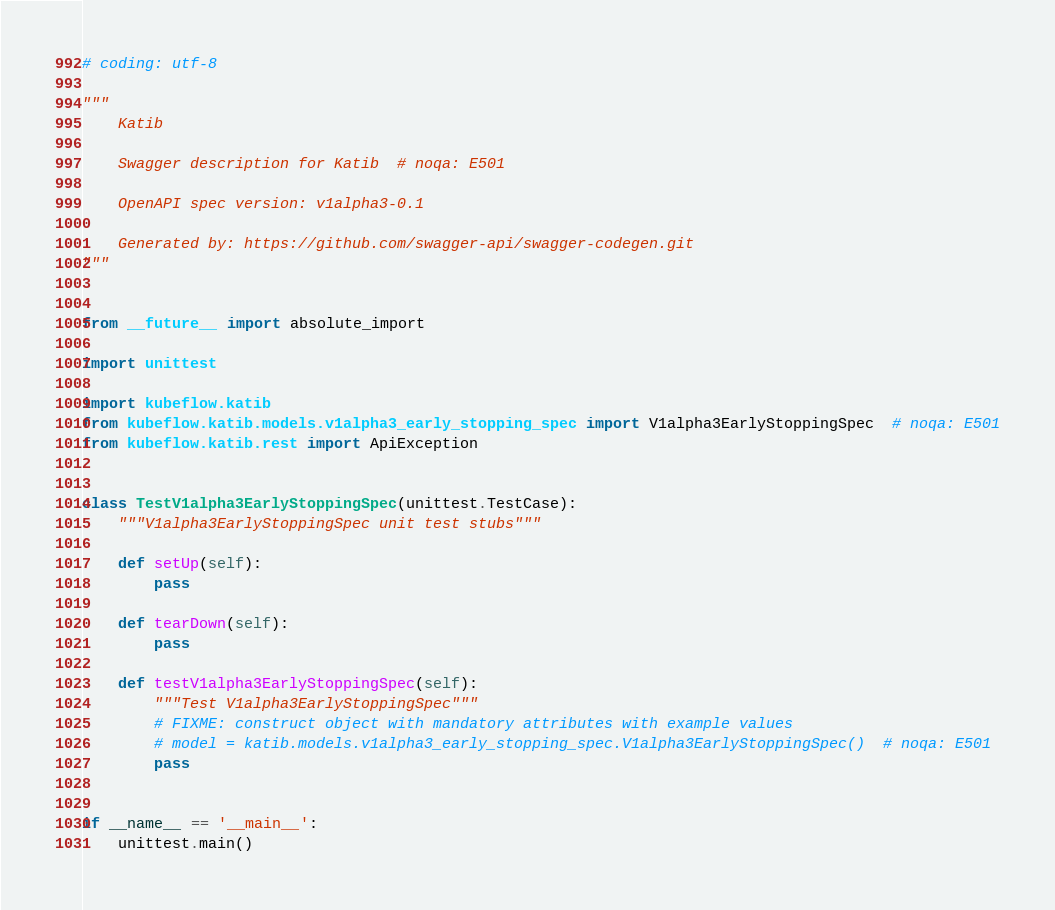<code> <loc_0><loc_0><loc_500><loc_500><_Python_># coding: utf-8

"""
    Katib

    Swagger description for Katib  # noqa: E501

    OpenAPI spec version: v1alpha3-0.1
    
    Generated by: https://github.com/swagger-api/swagger-codegen.git
"""


from __future__ import absolute_import

import unittest

import kubeflow.katib
from kubeflow.katib.models.v1alpha3_early_stopping_spec import V1alpha3EarlyStoppingSpec  # noqa: E501
from kubeflow.katib.rest import ApiException


class TestV1alpha3EarlyStoppingSpec(unittest.TestCase):
    """V1alpha3EarlyStoppingSpec unit test stubs"""

    def setUp(self):
        pass

    def tearDown(self):
        pass

    def testV1alpha3EarlyStoppingSpec(self):
        """Test V1alpha3EarlyStoppingSpec"""
        # FIXME: construct object with mandatory attributes with example values
        # model = katib.models.v1alpha3_early_stopping_spec.V1alpha3EarlyStoppingSpec()  # noqa: E501
        pass


if __name__ == '__main__':
    unittest.main()
</code> 